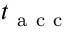Convert formula to latex. <formula><loc_0><loc_0><loc_500><loc_500>t _ { a c c }</formula> 